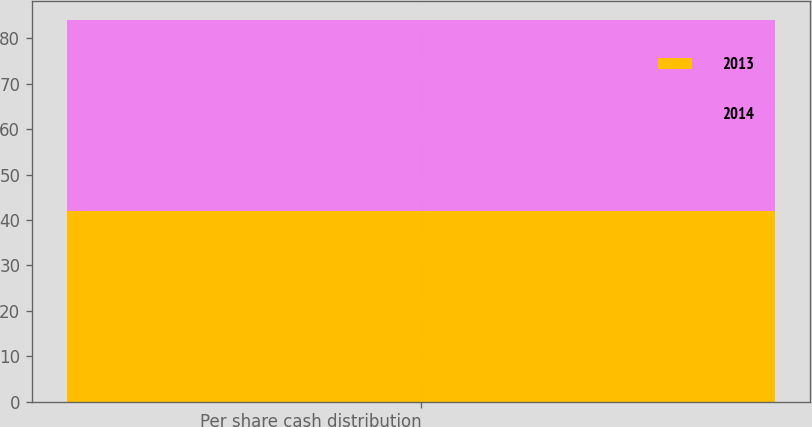Convert chart. <chart><loc_0><loc_0><loc_500><loc_500><stacked_bar_chart><ecel><fcel>Per share cash distribution<nl><fcel>2013<fcel>41.88<nl><fcel>2014<fcel>42.17<nl></chart> 